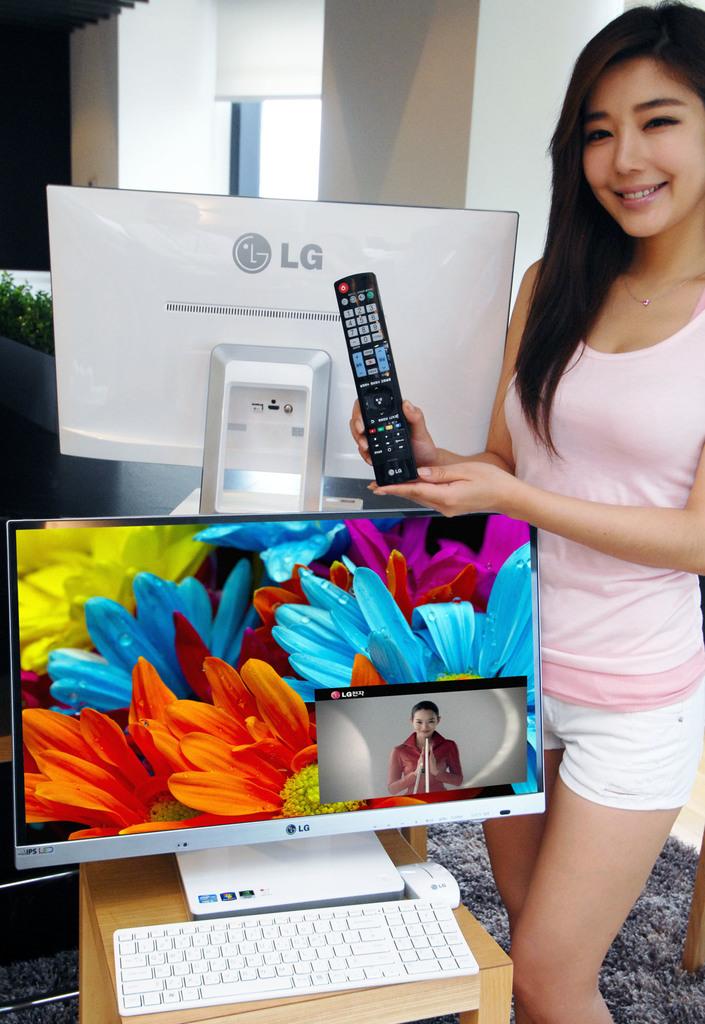What brand is the tv?
Give a very brief answer. Lg. What color is the brand name?
Your answer should be very brief. Answering does not require reading text in the image. 